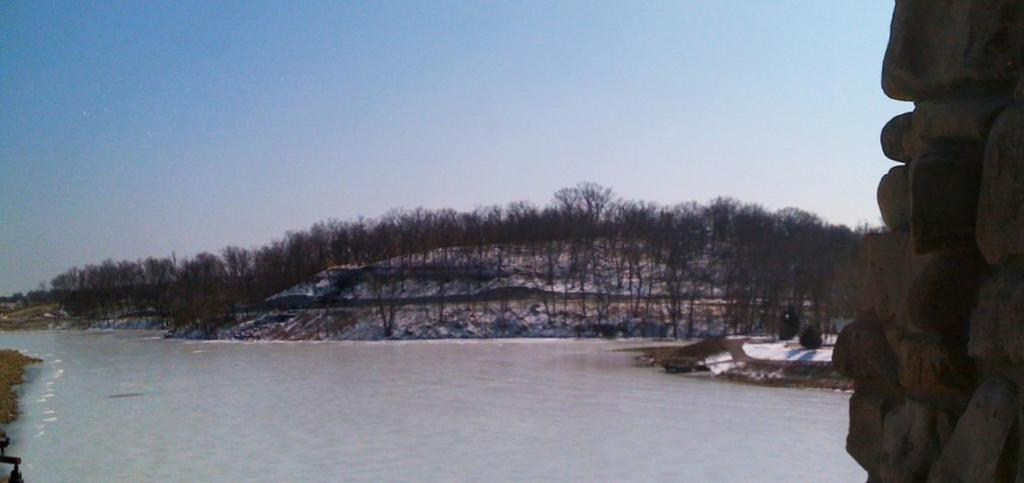What is located on the right side of the image in the foreground? There is a stone wall in the foreground of the image, on the right side. What can be seen in the background of the image? Water, trees, and the sky are visible in the background of the image. What type of bait is being used by the fish in the image? There are no fish or bait present in the image; it features a stone wall in the foreground and water, trees, and the sky in the background. 